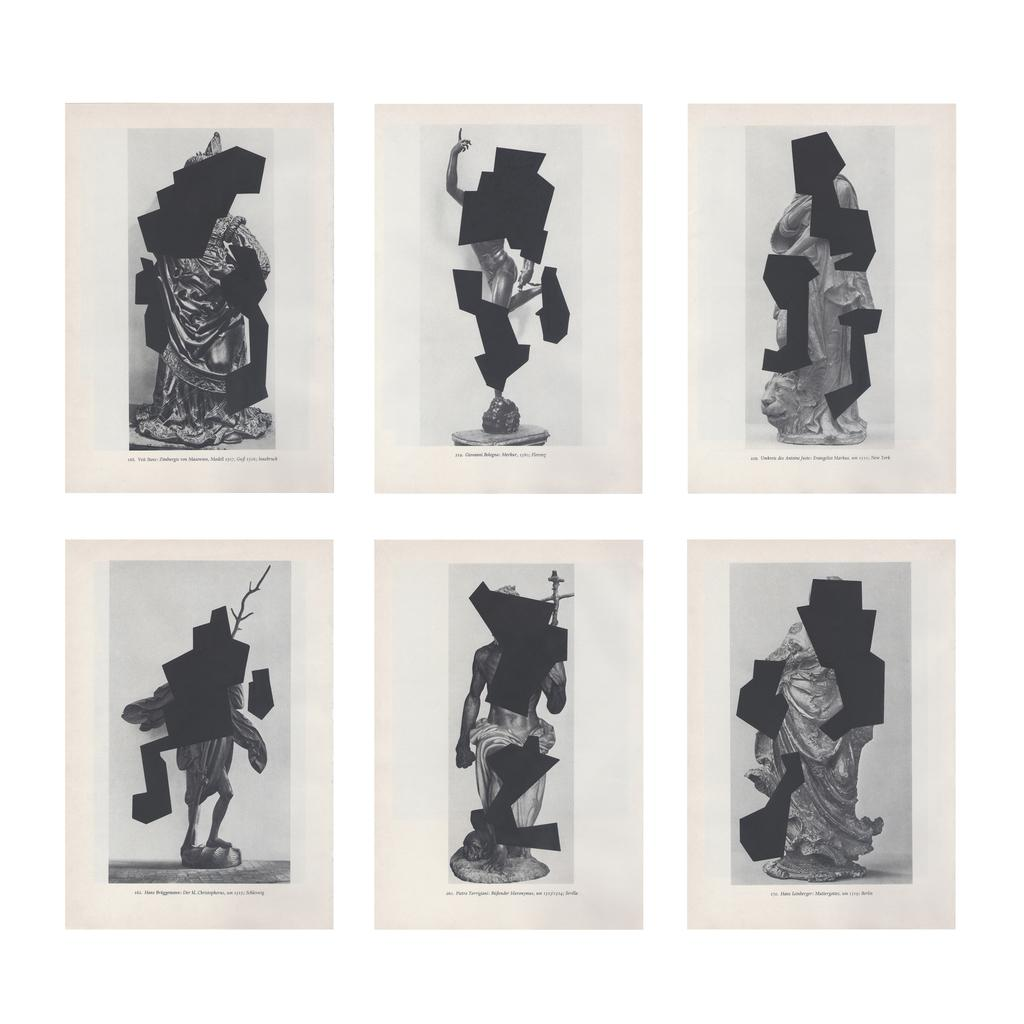How many statues are present in the image? There are six different types of statues in the image. What can be observed about the faces of the statues? The faces of the statues are covered with black shade. What type of rail can be seen connecting the statues in the image? There is no rail present in the image; it only features six different types of statues with black-shaded faces. 